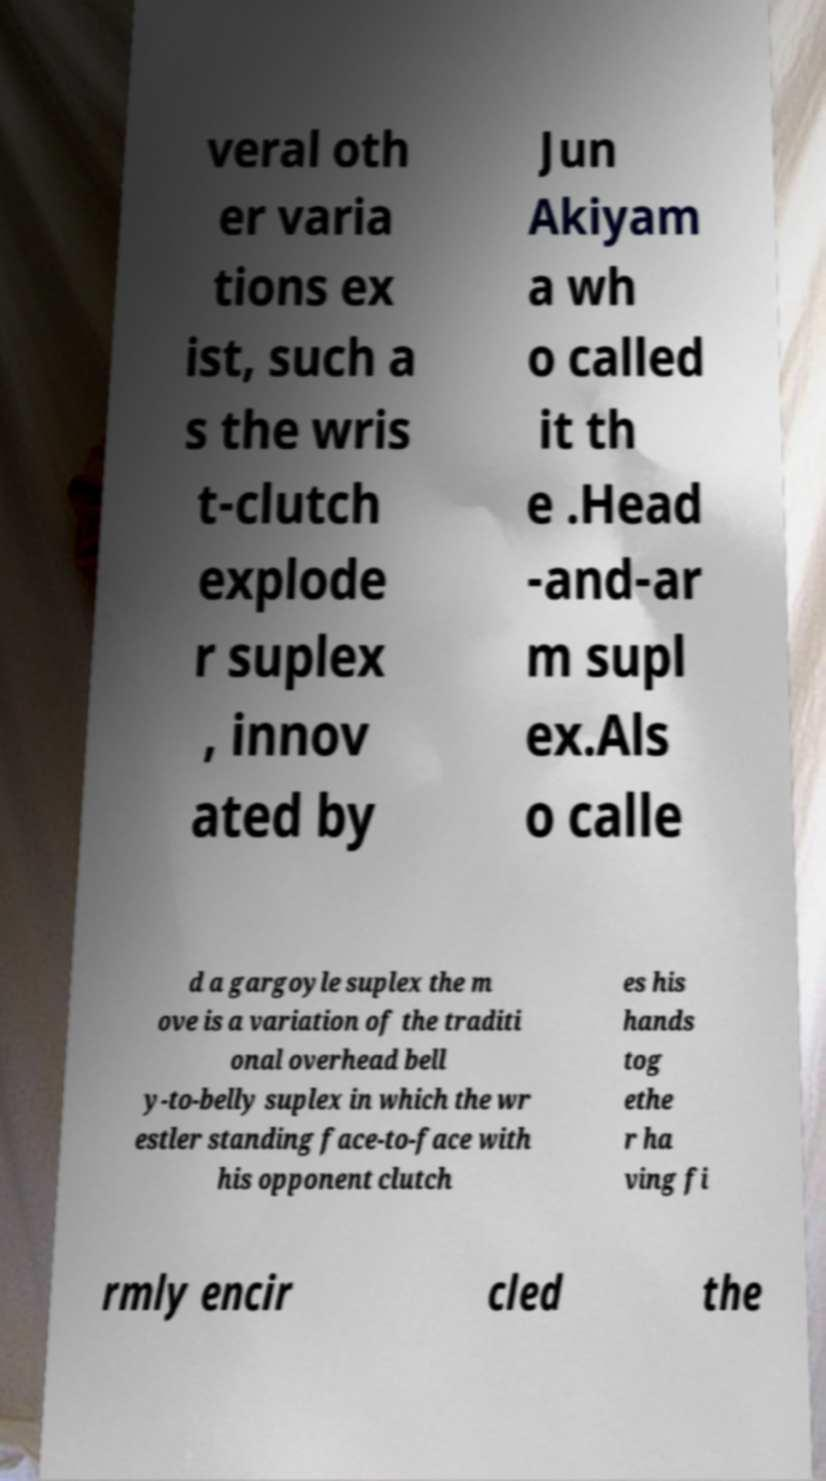Can you read and provide the text displayed in the image?This photo seems to have some interesting text. Can you extract and type it out for me? veral oth er varia tions ex ist, such a s the wris t-clutch explode r suplex , innov ated by Jun Akiyam a wh o called it th e .Head -and-ar m supl ex.Als o calle d a gargoyle suplex the m ove is a variation of the traditi onal overhead bell y-to-belly suplex in which the wr estler standing face-to-face with his opponent clutch es his hands tog ethe r ha ving fi rmly encir cled the 